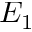<formula> <loc_0><loc_0><loc_500><loc_500>E _ { 1 }</formula> 